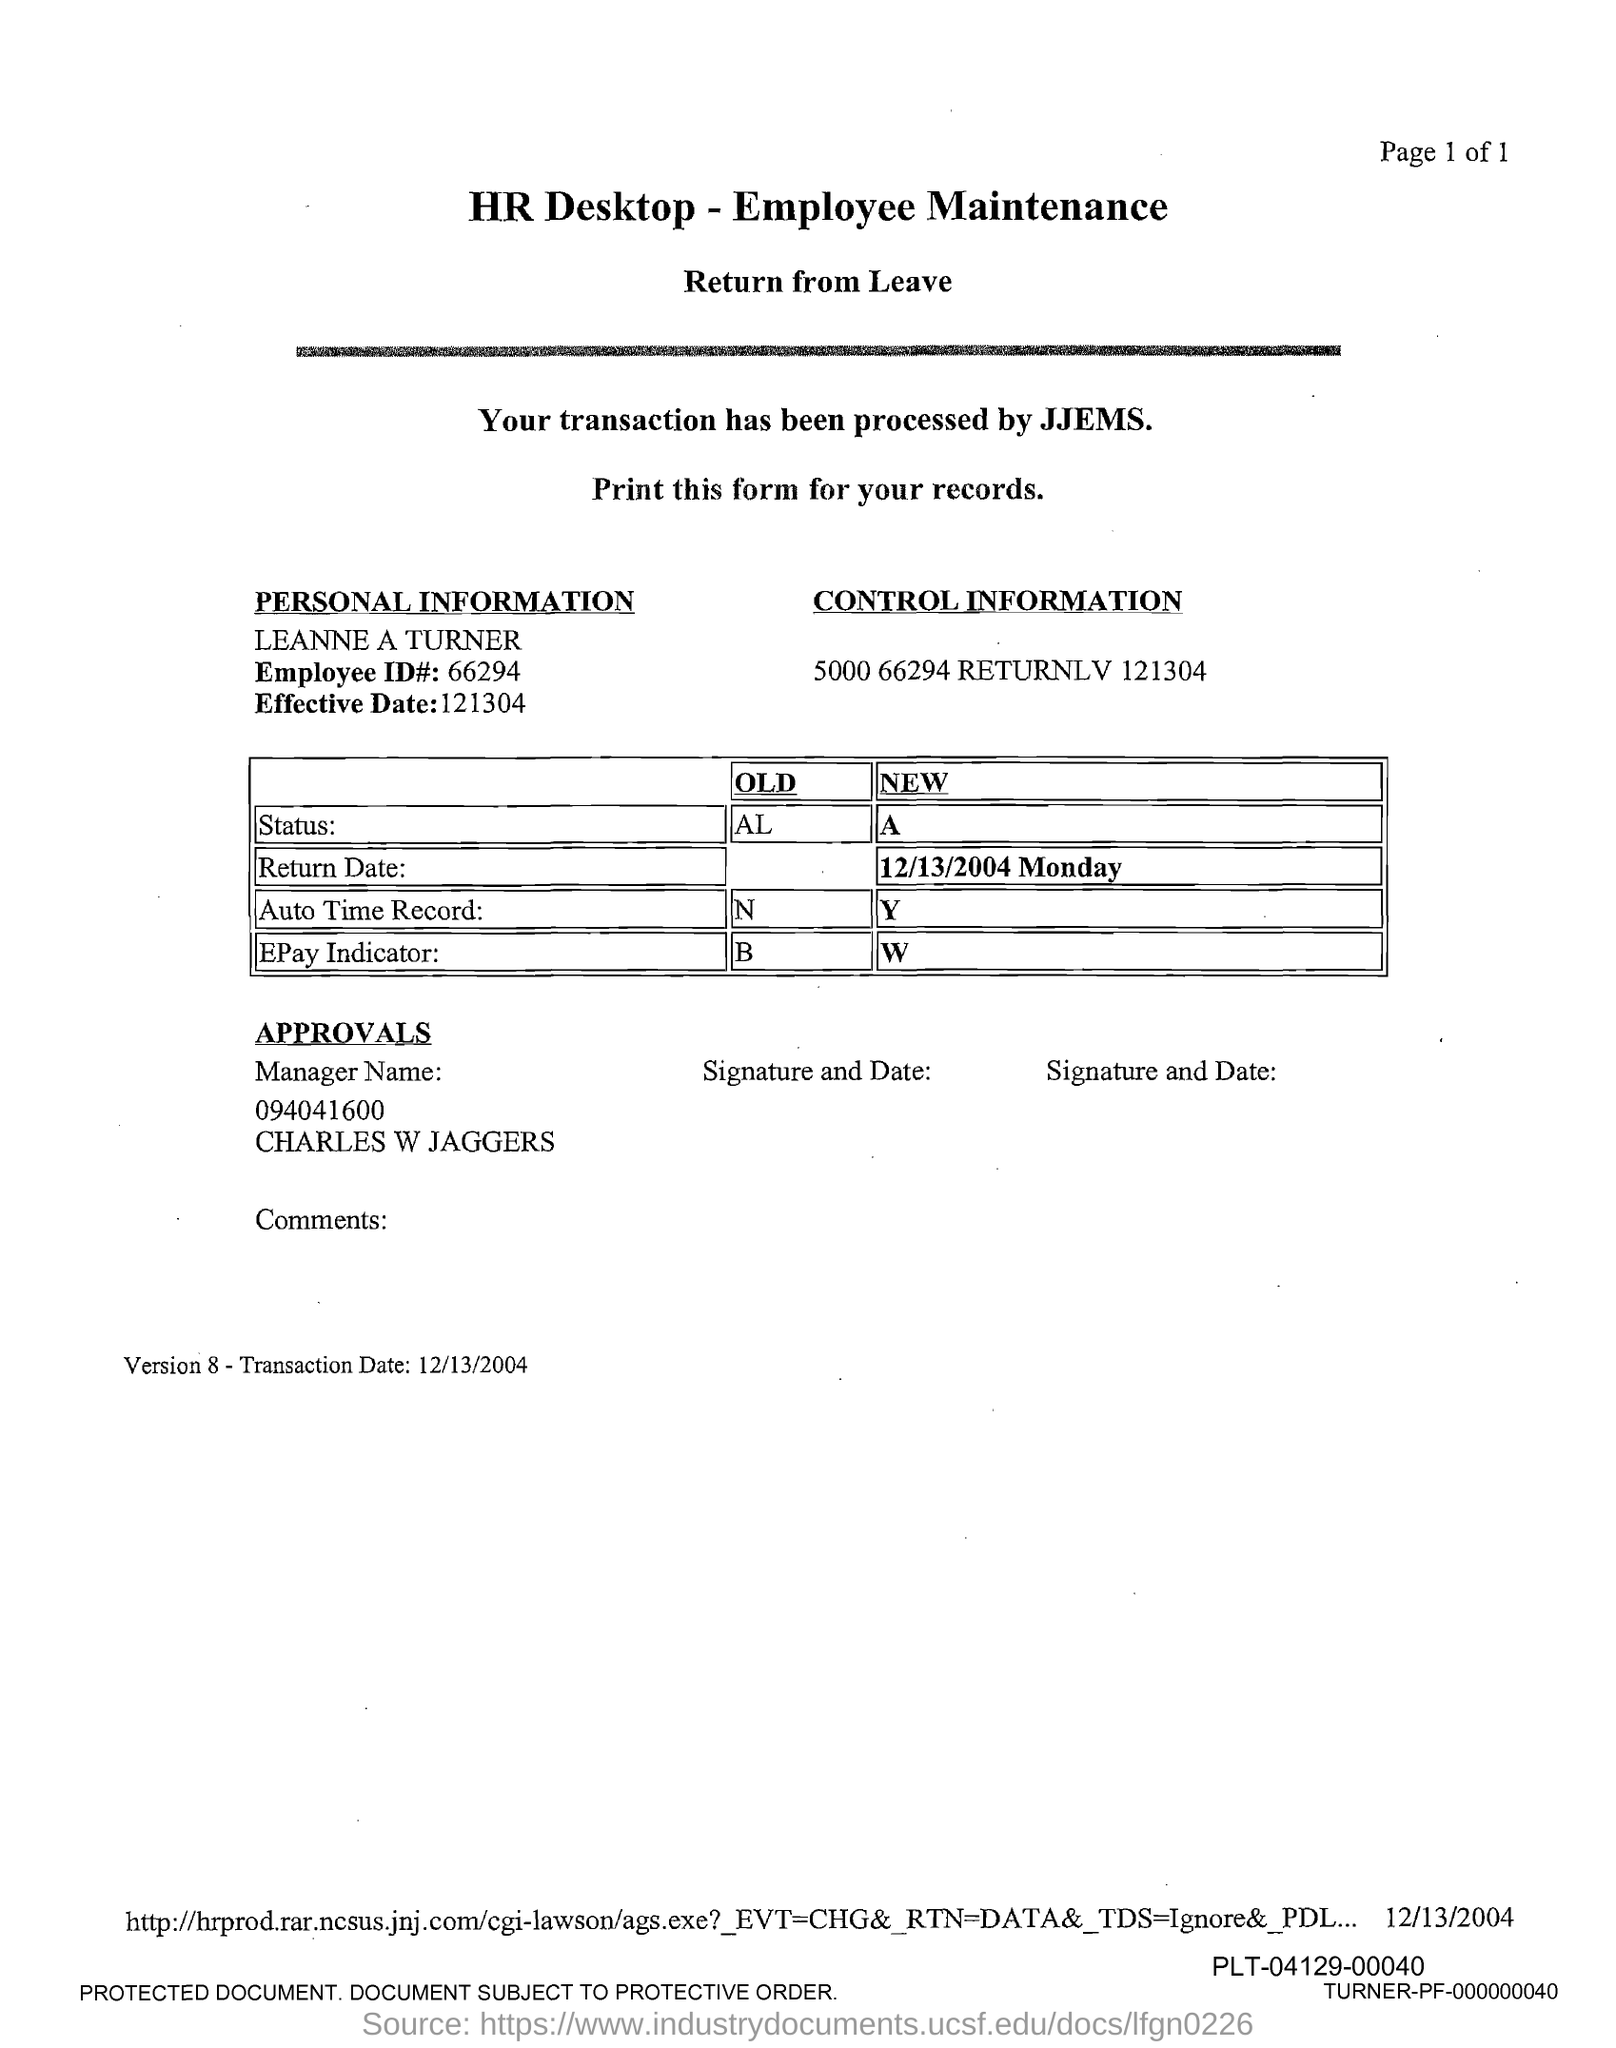Mention a couple of crucial points in this snapshot. The title of the document is 'HR Desktop - Employee Maintenance.' What is the New Epay indicator? We will discuss its details and how it can help you make informed decisions. What is the new status?" is a question that requires a decisive answer. The old Auto Time record is approximately N.. The Old Epay indicator is a financial metric that is used to determine the relative strength of a company's stock price performance. 